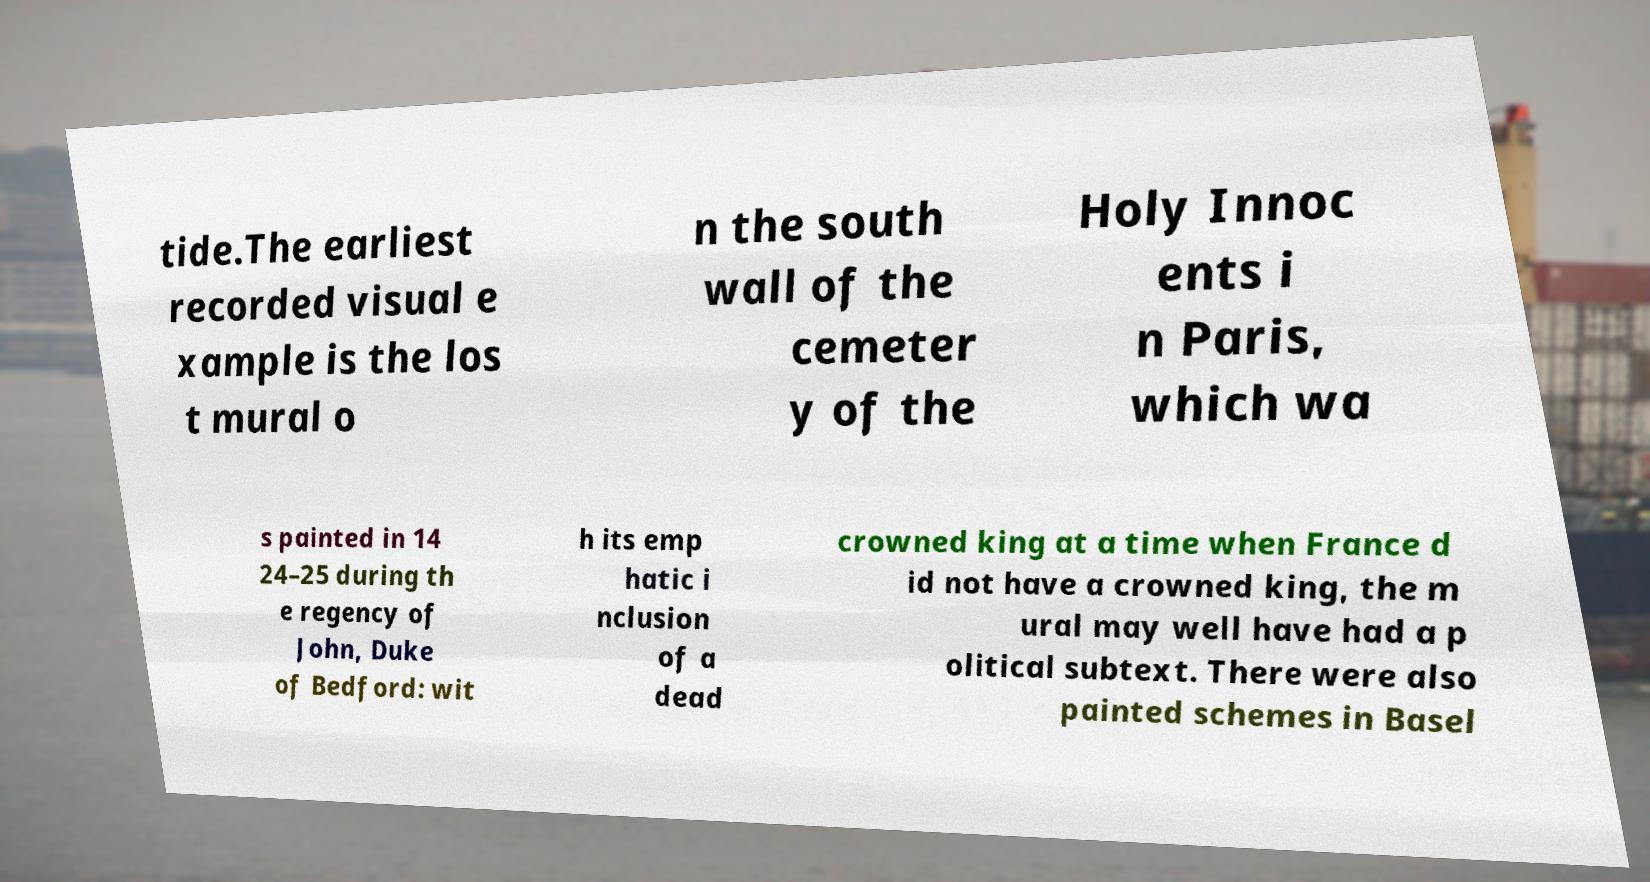Could you extract and type out the text from this image? tide.The earliest recorded visual e xample is the los t mural o n the south wall of the cemeter y of the Holy Innoc ents i n Paris, which wa s painted in 14 24–25 during th e regency of John, Duke of Bedford: wit h its emp hatic i nclusion of a dead crowned king at a time when France d id not have a crowned king, the m ural may well have had a p olitical subtext. There were also painted schemes in Basel 